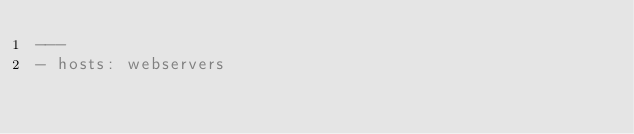<code> <loc_0><loc_0><loc_500><loc_500><_YAML_>---
- hosts: webservers
</code> 